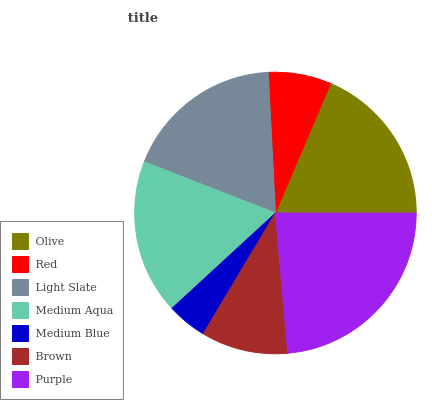Is Medium Blue the minimum?
Answer yes or no. Yes. Is Purple the maximum?
Answer yes or no. Yes. Is Red the minimum?
Answer yes or no. No. Is Red the maximum?
Answer yes or no. No. Is Olive greater than Red?
Answer yes or no. Yes. Is Red less than Olive?
Answer yes or no. Yes. Is Red greater than Olive?
Answer yes or no. No. Is Olive less than Red?
Answer yes or no. No. Is Medium Aqua the high median?
Answer yes or no. Yes. Is Medium Aqua the low median?
Answer yes or no. Yes. Is Brown the high median?
Answer yes or no. No. Is Purple the low median?
Answer yes or no. No. 